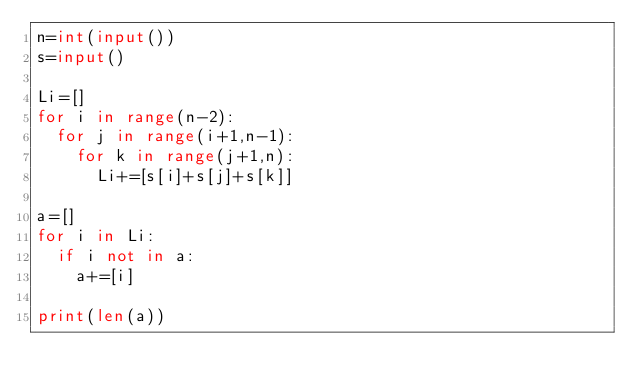Convert code to text. <code><loc_0><loc_0><loc_500><loc_500><_Python_>n=int(input())
s=input()

Li=[]
for i in range(n-2):
  for j in range(i+1,n-1):
    for k in range(j+1,n):
      Li+=[s[i]+s[j]+s[k]]

a=[]
for i in Li:
  if i not in a:
    a+=[i]

print(len(a))</code> 